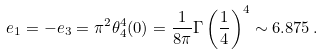Convert formula to latex. <formula><loc_0><loc_0><loc_500><loc_500>e _ { 1 } = - e _ { 3 } = \pi ^ { 2 } \theta _ { 4 } ^ { 4 } ( 0 ) = \frac { 1 } { 8 \pi } \Gamma \left ( \frac { 1 } { 4 } \right ) ^ { 4 } \sim 6 . 8 7 5 \, .</formula> 